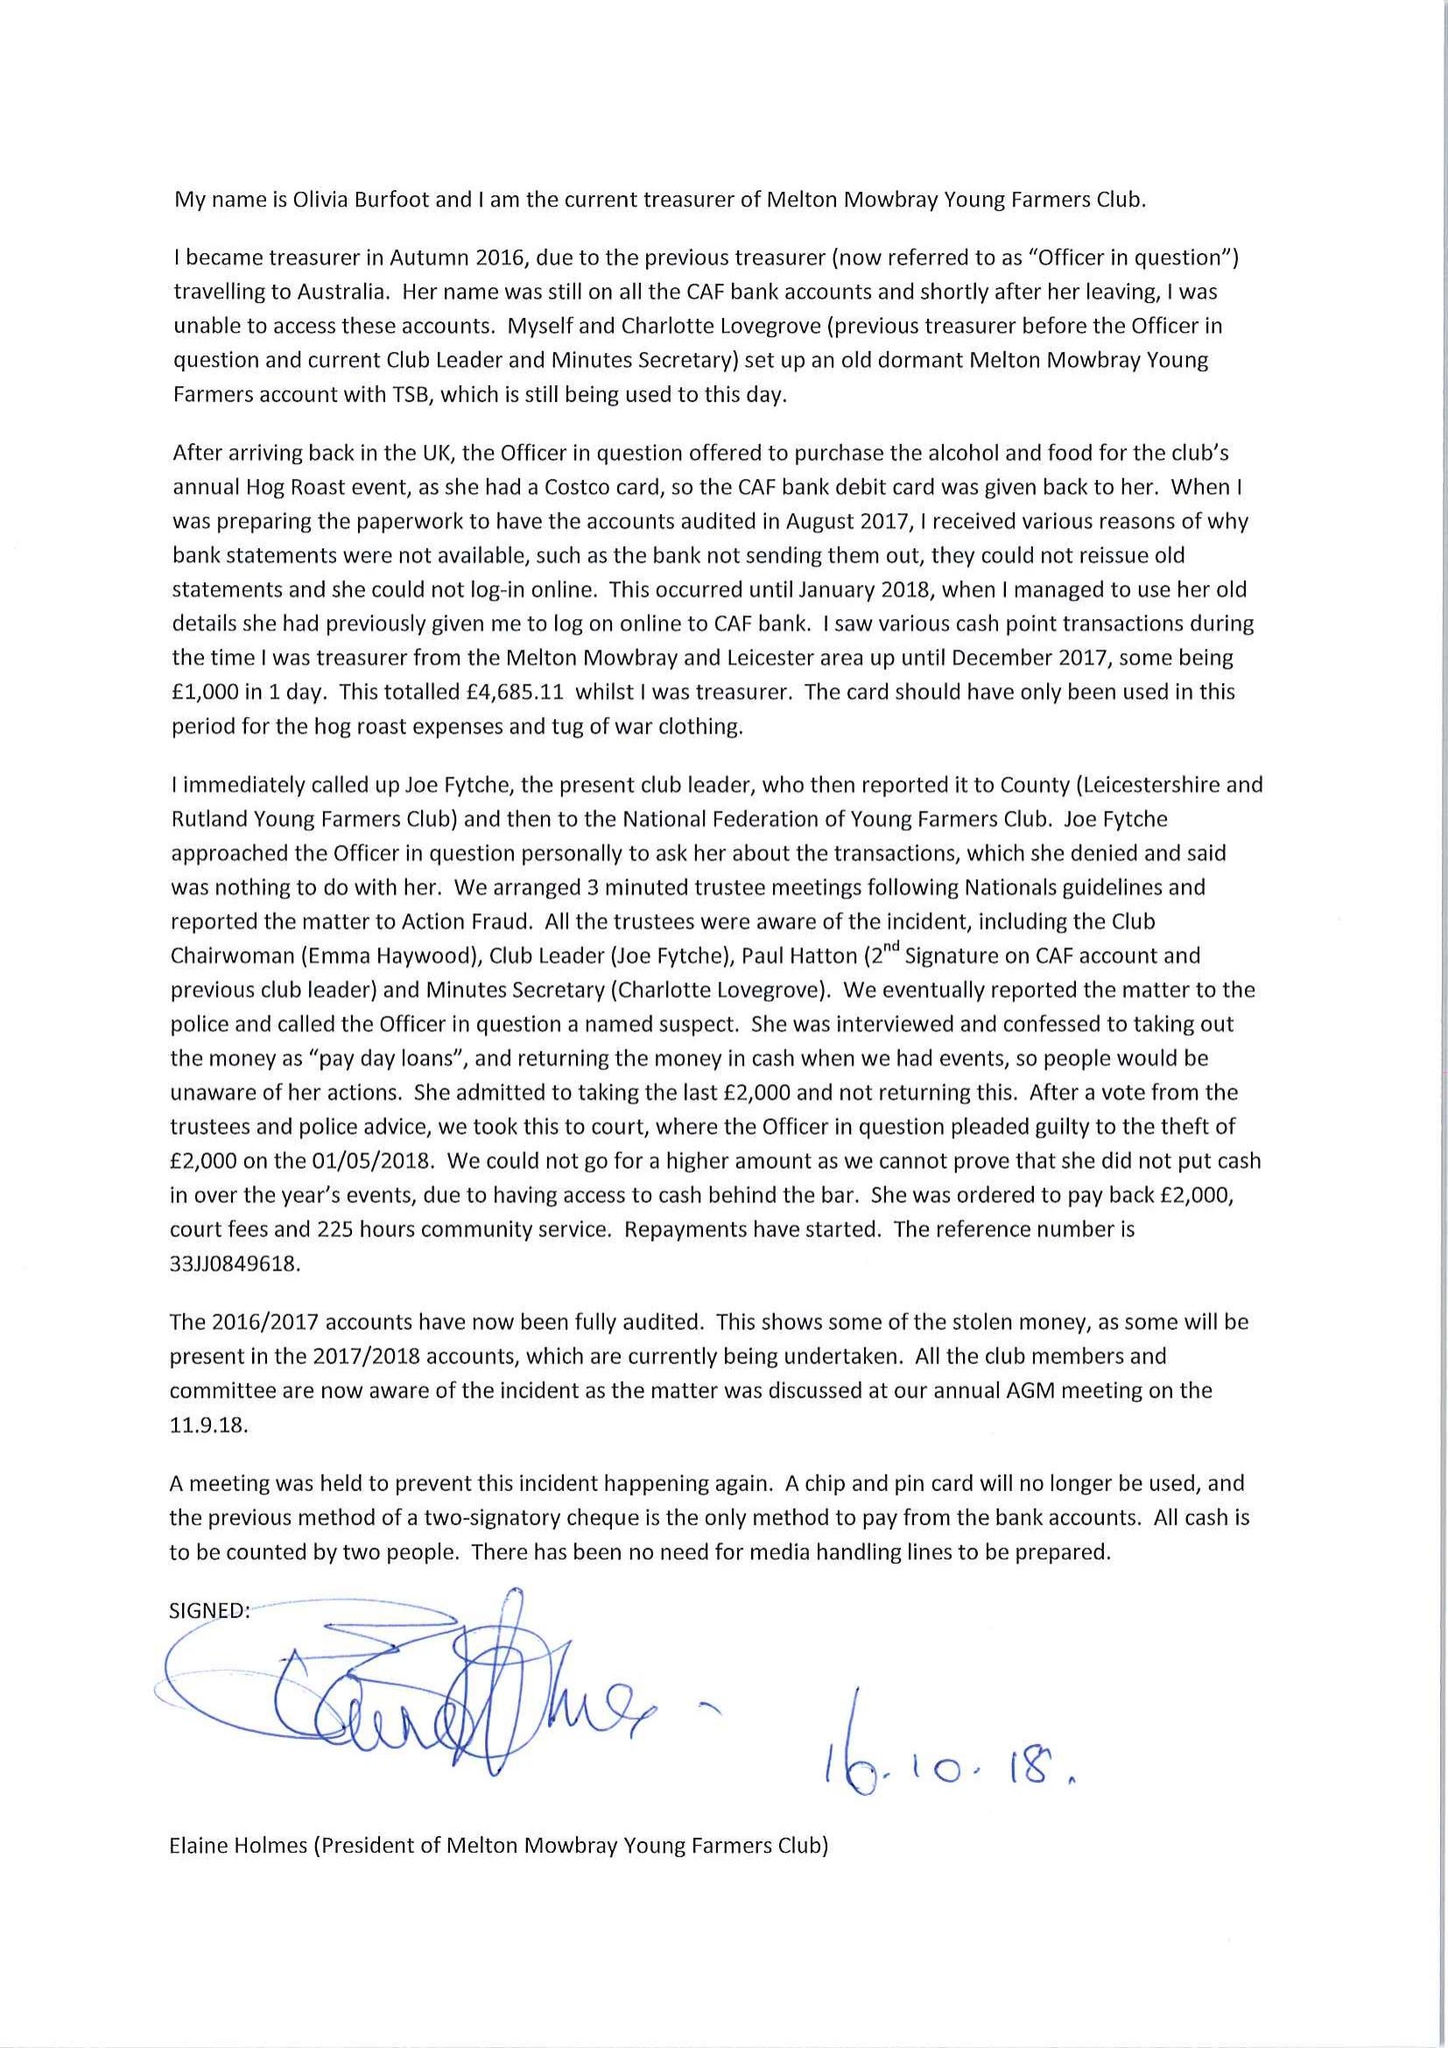What is the value for the income_annually_in_british_pounds?
Answer the question using a single word or phrase. 31628.00 